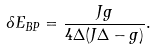<formula> <loc_0><loc_0><loc_500><loc_500>\delta E _ { B P } = \frac { J g } { 4 \Delta ( J \Delta - g ) } .</formula> 